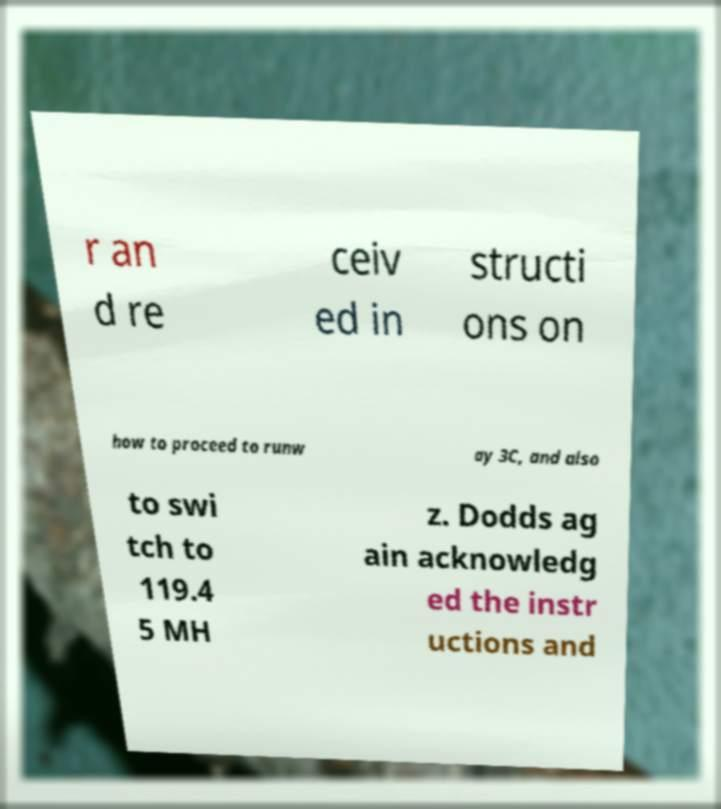There's text embedded in this image that I need extracted. Can you transcribe it verbatim? r an d re ceiv ed in structi ons on how to proceed to runw ay 3C, and also to swi tch to 119.4 5 MH z. Dodds ag ain acknowledg ed the instr uctions and 